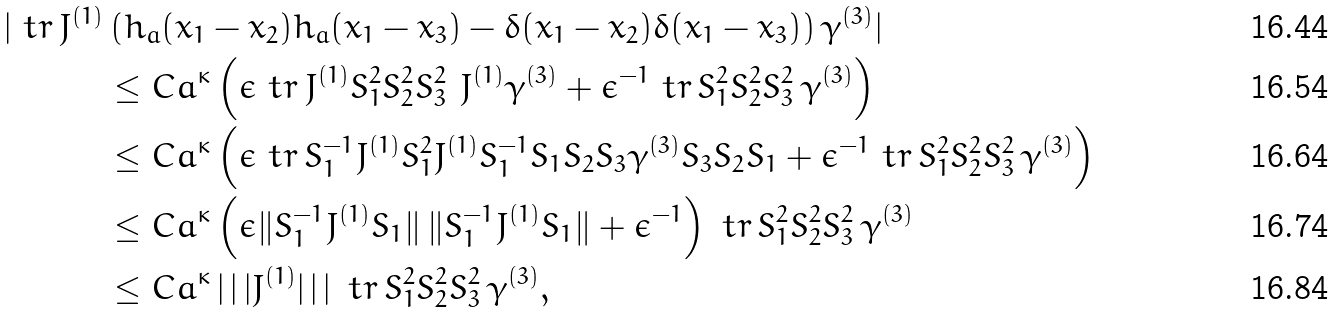<formula> <loc_0><loc_0><loc_500><loc_500>| \ t r \, J ^ { ( 1 ) } & \left ( h _ { a } ( x _ { 1 } - x _ { 2 } ) h _ { a } ( x _ { 1 } - x _ { 3 } ) - \delta ( x _ { 1 } - x _ { 2 } ) \delta ( x _ { 1 } - x _ { 3 } ) \right ) \gamma ^ { ( 3 ) } | \\ & \leq C a ^ { \kappa } \left ( \epsilon \ t r \, J ^ { ( 1 ) } S _ { 1 } ^ { 2 } S _ { 2 } ^ { 2 } S _ { 3 } ^ { 2 } \ J ^ { ( 1 ) } \gamma ^ { ( 3 ) } + { \epsilon } ^ { - 1 } \ t r \, S _ { 1 } ^ { 2 } S _ { 2 } ^ { 2 } S _ { 3 } ^ { 2 } \, \gamma ^ { ( 3 ) } \right ) \\ & \leq C a ^ { \kappa } \left ( \epsilon \ t r \, S _ { 1 } ^ { - 1 } J ^ { ( 1 ) } S _ { 1 } ^ { 2 } J ^ { ( 1 ) } S _ { 1 } ^ { - 1 } S _ { 1 } S _ { 2 } S _ { 3 } \gamma ^ { ( 3 ) } S _ { 3 } S _ { 2 } S _ { 1 } + { \epsilon } ^ { - 1 } \ t r \, S _ { 1 } ^ { 2 } S _ { 2 } ^ { 2 } S _ { 3 } ^ { 2 } \, \gamma ^ { ( 3 ) } \right ) \\ & \leq C a ^ { \kappa } \left ( \epsilon \| S _ { 1 } ^ { - 1 } J ^ { ( 1 ) } S _ { 1 } \| \, \| S _ { 1 } ^ { - 1 } J ^ { ( 1 ) } S _ { 1 } \| + \epsilon ^ { - 1 } \right ) \ t r \, S _ { 1 } ^ { 2 } S _ { 2 } ^ { 2 } S _ { 3 } ^ { 2 } \, \gamma ^ { ( 3 ) } \\ & \leq C a ^ { \kappa } \, | \, | \, | J ^ { ( 1 ) } | \, | \, | \, \ t r \, S _ { 1 } ^ { 2 } S _ { 2 } ^ { 2 } S _ { 3 } ^ { 2 } \, \gamma ^ { ( 3 ) } ,</formula> 